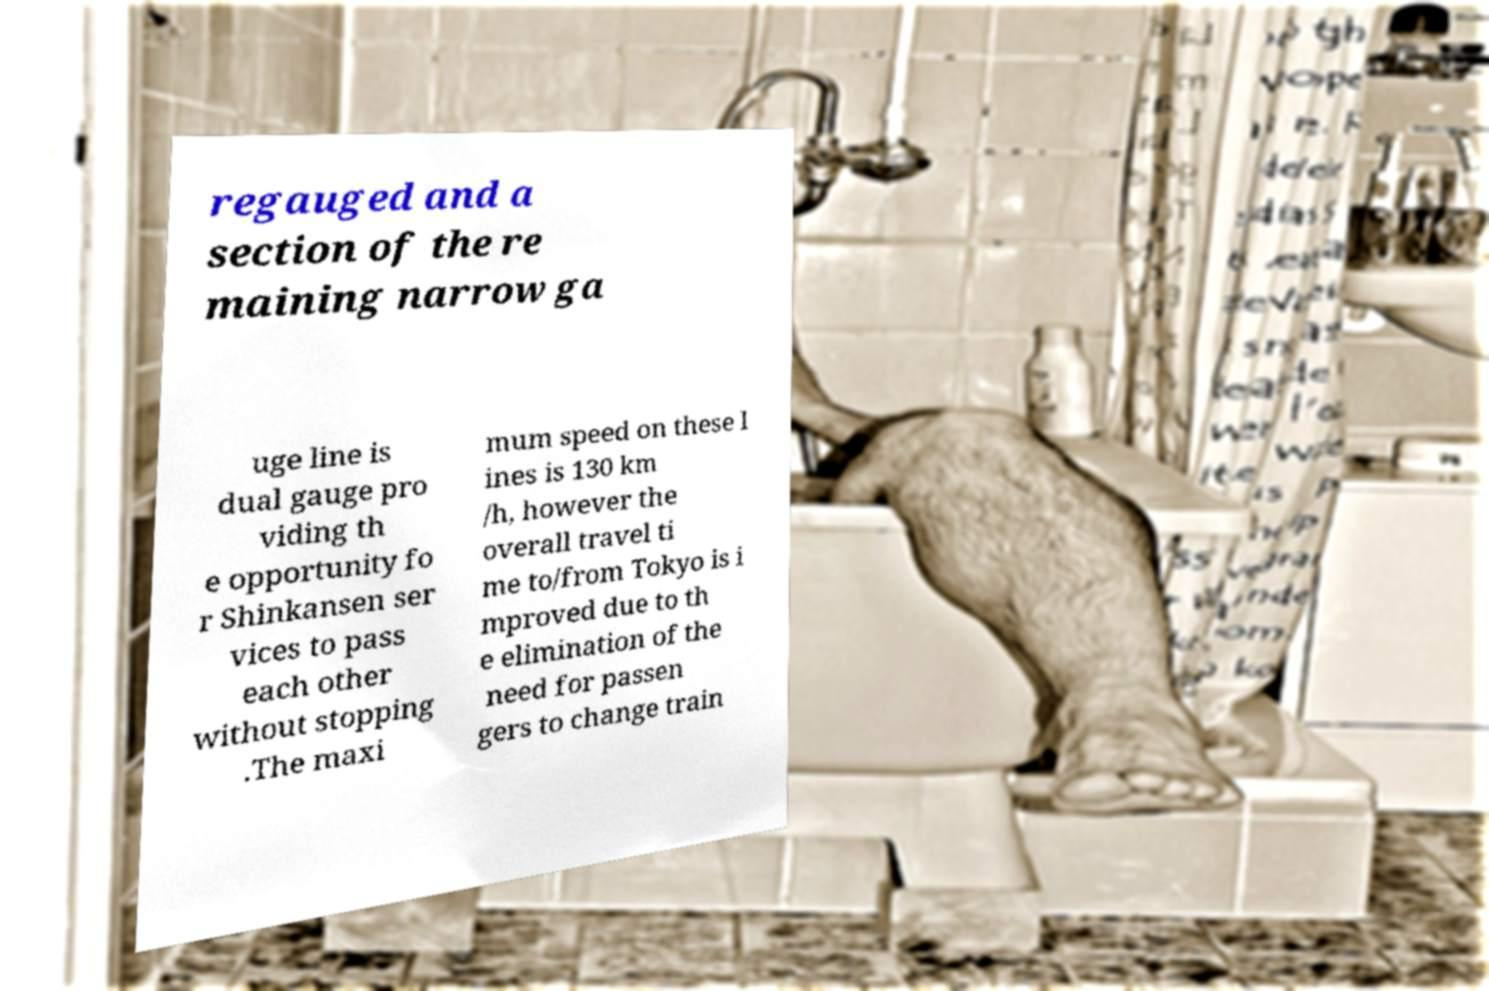For documentation purposes, I need the text within this image transcribed. Could you provide that? regauged and a section of the re maining narrow ga uge line is dual gauge pro viding th e opportunity fo r Shinkansen ser vices to pass each other without stopping .The maxi mum speed on these l ines is 130 km /h, however the overall travel ti me to/from Tokyo is i mproved due to th e elimination of the need for passen gers to change train 